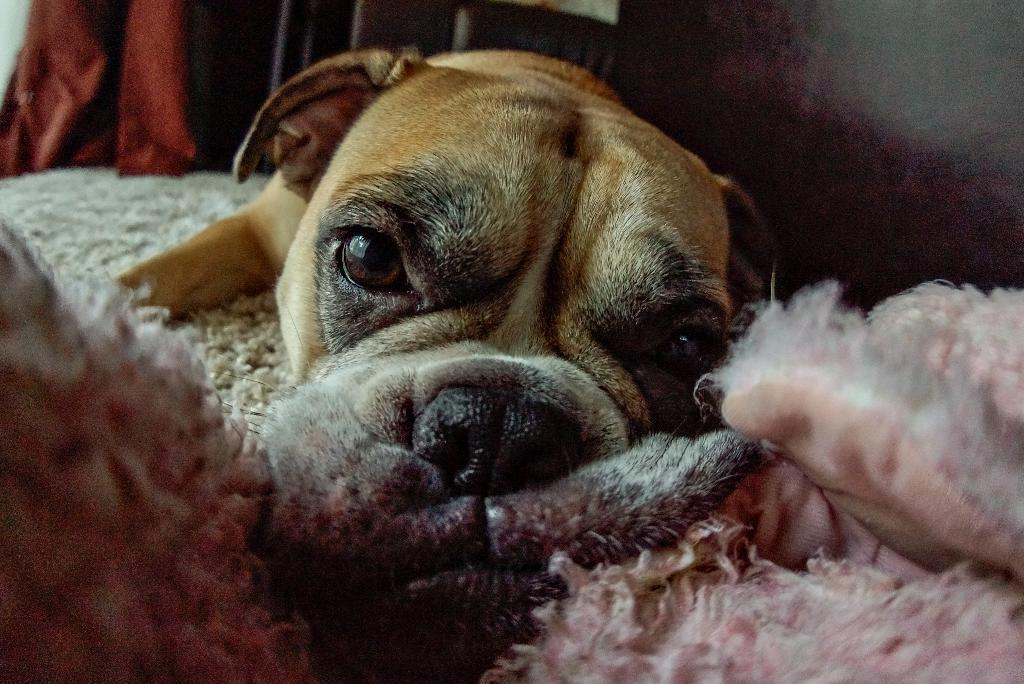What type of animal is present in the image? There is a dog in the image. What is located at the bottom of the image? There is a mat at the bottom of the image. What can be seen in the background of the image? There is a curtain in the background of the image. How many yaks are visible in the image? There are no yaks present in the image. Are the beds in the image folded or unfolded? There are no beds present in the image. 